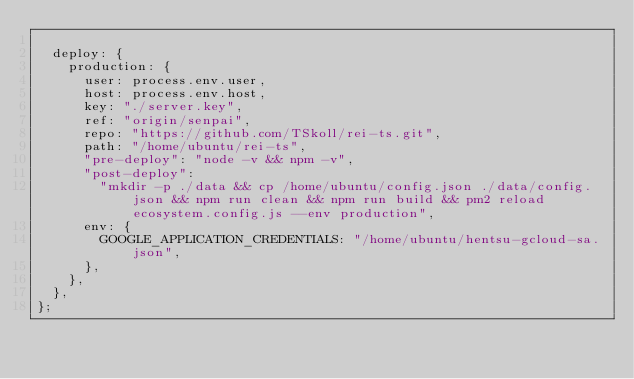Convert code to text. <code><loc_0><loc_0><loc_500><loc_500><_JavaScript_>
  deploy: {
    production: {
      user: process.env.user,
      host: process.env.host,
      key: "./server.key",
      ref: "origin/senpai",
      repo: "https://github.com/TSkoll/rei-ts.git",
      path: "/home/ubuntu/rei-ts",
      "pre-deploy": "node -v && npm -v",
      "post-deploy":
        "mkdir -p ./data && cp /home/ubuntu/config.json ./data/config.json && npm run clean && npm run build && pm2 reload ecosystem.config.js --env production",
      env: {
        GOOGLE_APPLICATION_CREDENTIALS: "/home/ubuntu/hentsu-gcloud-sa.json",
      },
    },
  },
};
</code> 